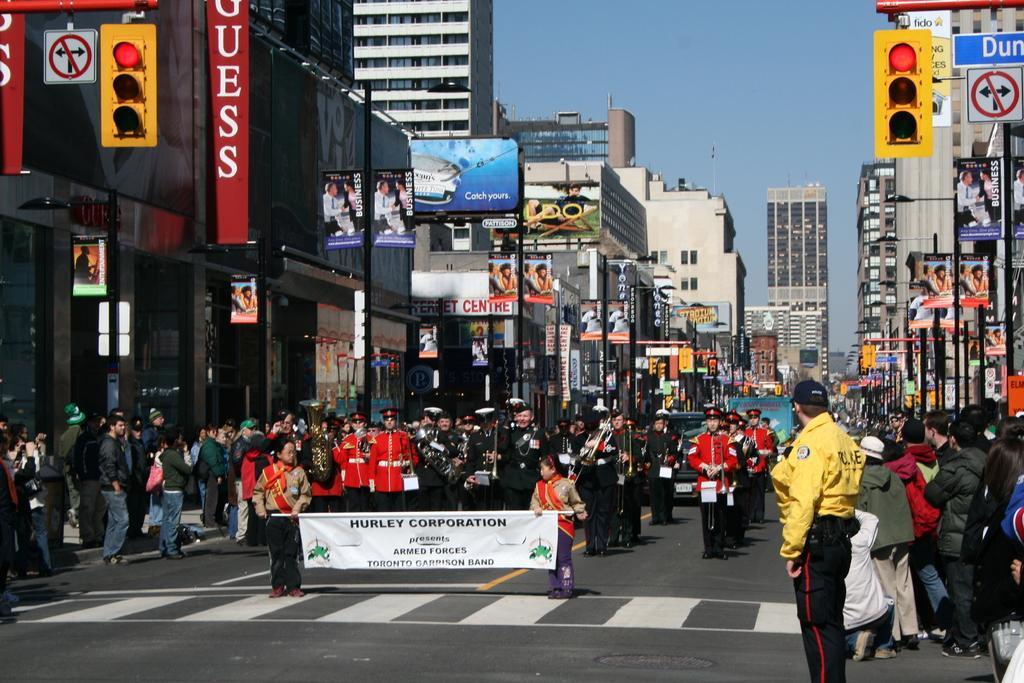In one or two sentences, can you explain what this image depicts? In the center of the image we can see a group of people are standing, some of them are holding musical instruments, board, bags. In the background of the image we can see buildings, boards, poles, traffic lights. At the top of the image there is a sky. At the bottom of the image there is a road. 